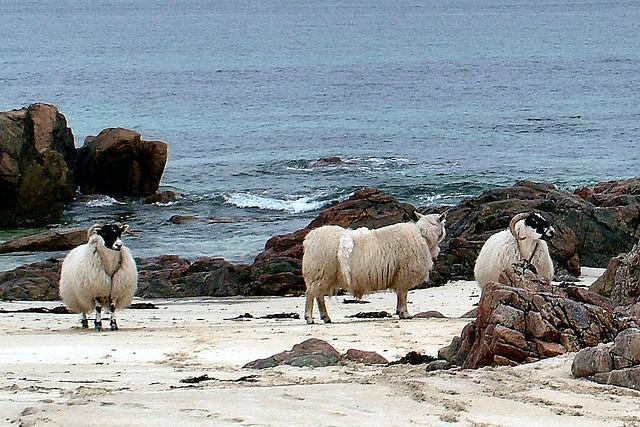How many sheep are in the photo?
Give a very brief answer. 3. 